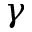<formula> <loc_0><loc_0><loc_500><loc_500>\gamma</formula> 